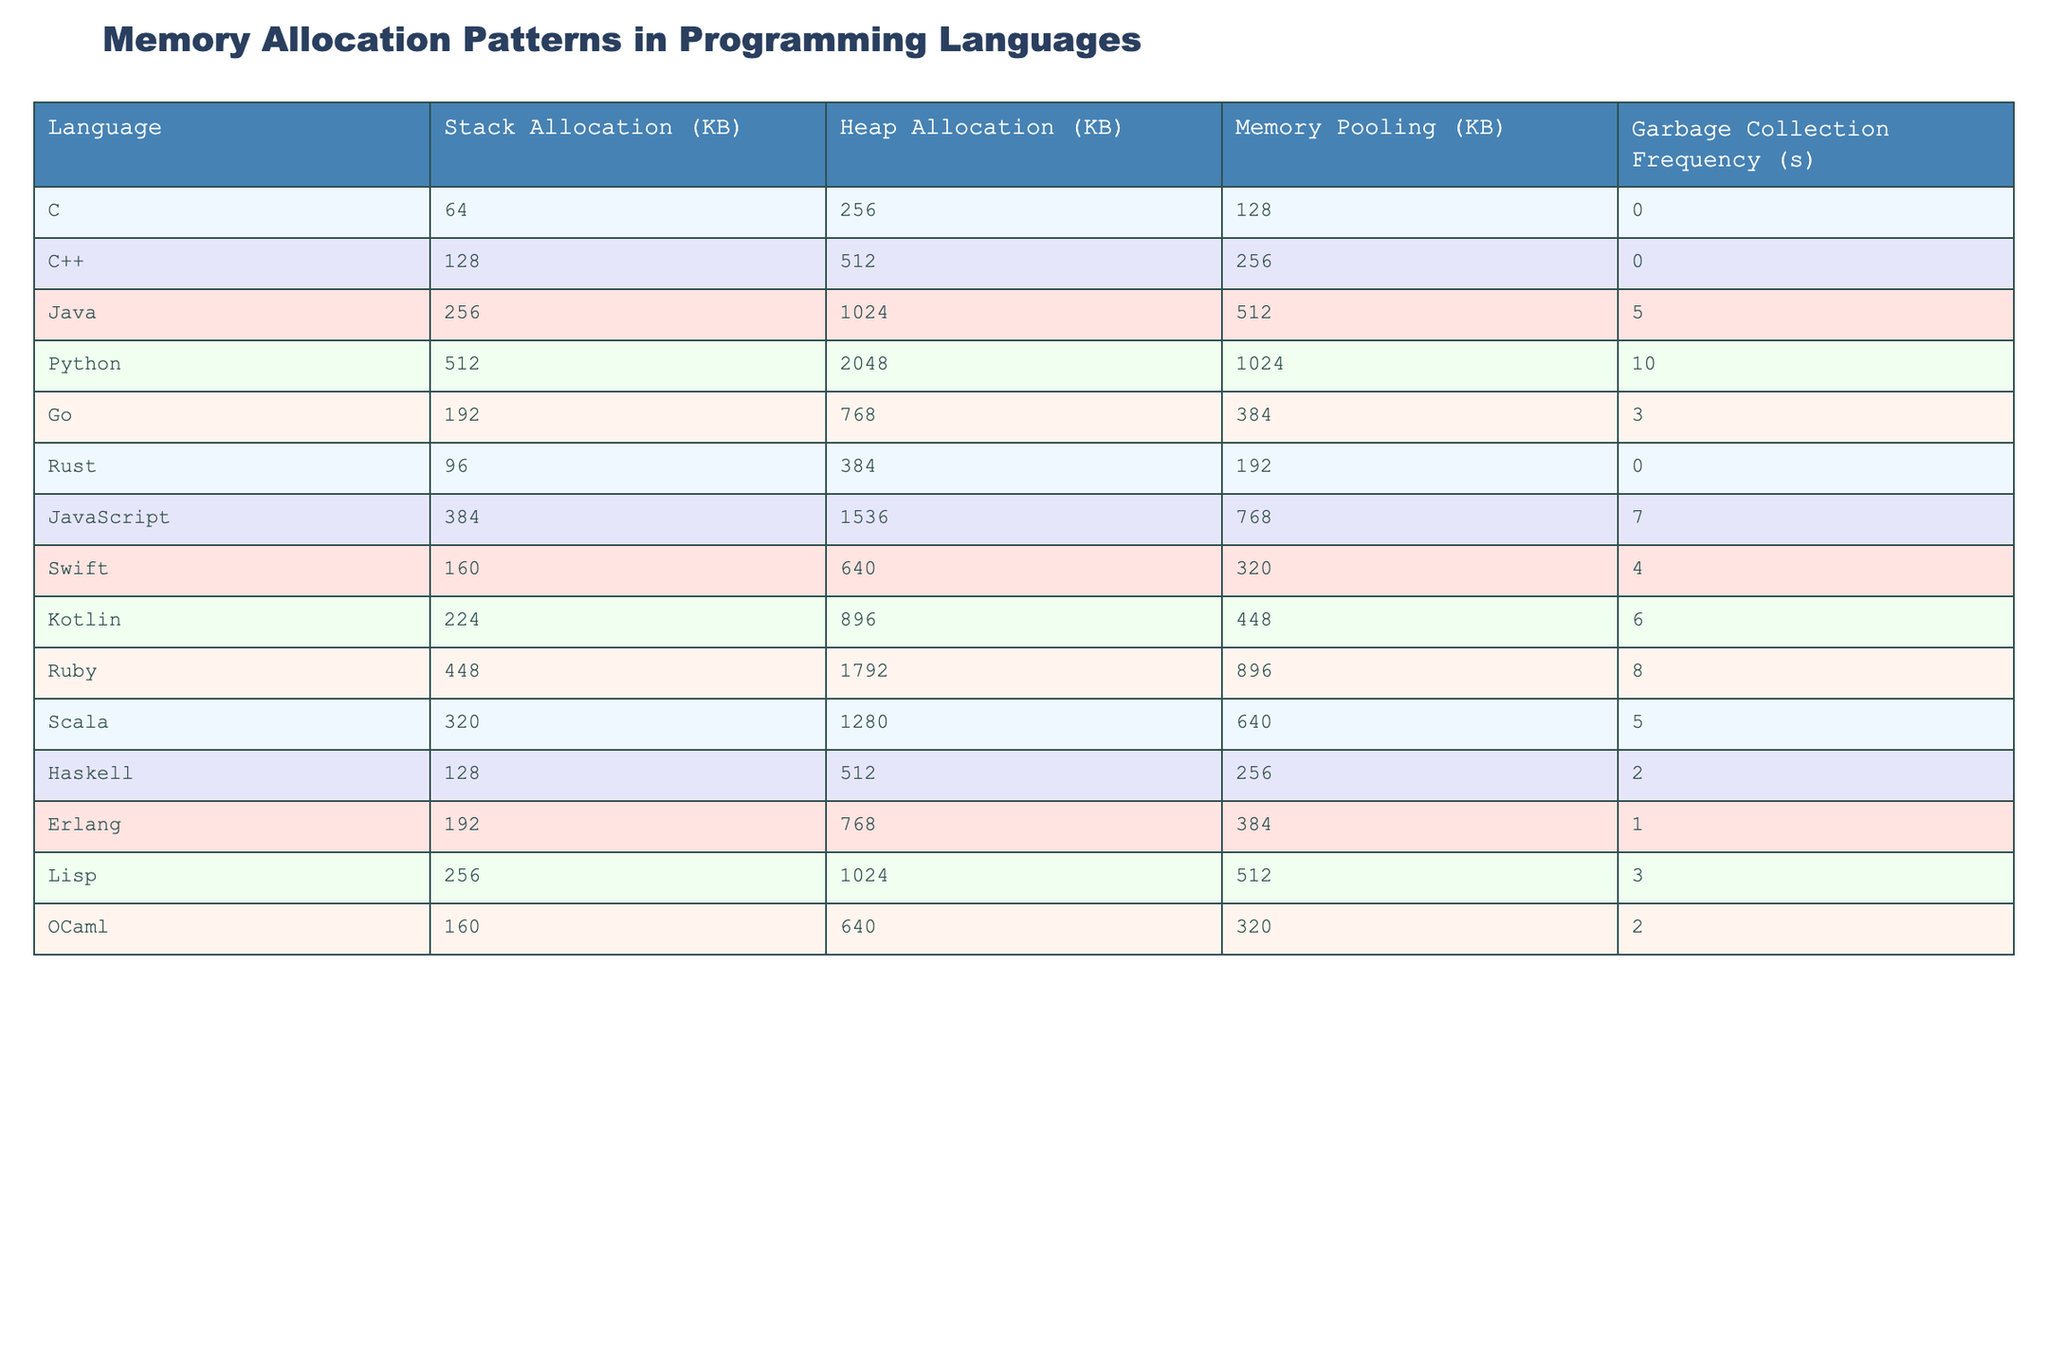What is the stack allocation size for Python? In the table, the value for stack allocation specific to Python is listed under the "Stack Allocation (KB)" column, which shows 512 KB.
Answer: 512 KB Which language has the highest heap allocation? By comparing the values in the "Heap Allocation (KB)" column, Ruby shows the highest heap allocation value of 1792 KB.
Answer: Ruby Is there a language with both stack and heap allocation sizes greater than 800 KB? Looking at the table, both Java and Python have stack allocation less than 800 KB but their heap allocations are greater than 800 KB. Therefore, the answer is yes.
Answer: Yes What is the total memory pooling size for C++ and Go combined? For C++, the memory pooling is 256 KB, and for Go, it is 384 KB. Adding both gives: 256 KB + 384 KB = 640 KB.
Answer: 640 KB Which language has the highest garbage collection frequency? By reviewing the "Garbage Collection Frequency (s)" column, Python has the highest frequency at 10 seconds.
Answer: Python What is the median stack allocation size among all languages? First, we list the stack allocation sizes: 64, 128, 256, 512, 192, 96, 384, 160, 224, 448, 320, 128, 192, 256, 160. There are 15 values. The median is the average of the 7th and 8th values when sorted (96, 128, 128, 160, 160, 192, 192, 224, 256, 256, 320, 384, 448, 512). The two middle values are 192 and 160, so (192 + 160)/2 = 176.
Answer: 176 Which language has the least garbage collection frequency, and what is its value? Examining the garbage collection frequency values, Rust has a frequency of 0 seconds, indicating no garbage collection.
Answer: Rust, 0 seconds What is the difference in memory pooling size between Ruby and Swift? Ruby has a memory pooling of 896 KB while Swift's is 320 KB. The difference is calculated as 896 KB - 320 KB = 576 KB.
Answer: 576 KB For languages with garbage collection, what is the average heap allocation size? The languages that implement garbage collection are Java, Python, JavaScript, Kotlin, Ruby, Scala, Haskell, and Lisp. Their heap allocation sizes are: 1024, 2048, 1536, 896, 1792, 1280, 512, and 1024. The total is 1024 + 2048 + 1536 + 896 + 1792 + 1280 + 512 + 1024 = 9212. The average is 9212 / 8 = 1151.5.
Answer: 1151.5 Which language has both the highest stack allocation and the second-highest heap allocation? The highest stack allocation is 512 KB (Python), and the second-highest heap allocation is 1792 KB (Ruby). Both belong to different languages, confirming the question's logic. This means there is no single language matching both criteria plainly.
Answer: No single language meets both criteria 